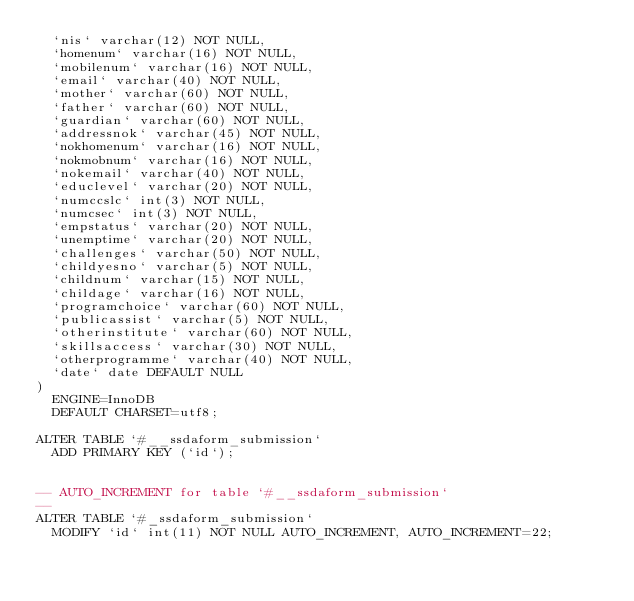<code> <loc_0><loc_0><loc_500><loc_500><_SQL_>  `nis` varchar(12) NOT NULL,
  `homenum` varchar(16) NOT NULL,
  `mobilenum` varchar(16) NOT NULL,
  `email` varchar(40) NOT NULL,
  `mother` varchar(60) NOT NULL,
  `father` varchar(60) NOT NULL,
  `guardian` varchar(60) NOT NULL,
  `addressnok` varchar(45) NOT NULL,
  `nokhomenum` varchar(16) NOT NULL,
  `nokmobnum` varchar(16) NOT NULL,
  `nokemail` varchar(40) NOT NULL,
  `educlevel` varchar(20) NOT NULL,
  `numccslc` int(3) NOT NULL,
  `numcsec` int(3) NOT NULL,
  `empstatus` varchar(20) NOT NULL,
  `unemptime` varchar(20) NOT NULL,
  `challenges` varchar(50) NOT NULL,
  `childyesno` varchar(5) NOT NULL,
  `childnum` varchar(15) NOT NULL,
  `childage` varchar(16) NOT NULL,
  `programchoice` varchar(60) NOT NULL,
  `publicassist` varchar(5) NOT NULL,
  `otherinstitute` varchar(60) NOT NULL,
  `skillsaccess` varchar(30) NOT NULL,
  `otherprogramme` varchar(40) NOT NULL,
  `date` date DEFAULT NULL
) 
	ENGINE=InnoDB 
	DEFAULT CHARSET=utf8;
	
ALTER TABLE `#__ssdaform_submission`
  ADD PRIMARY KEY (`id`);


-- AUTO_INCREMENT for table `#__ssdaform_submission`
--
ALTER TABLE `#_ssdaform_submission`
  MODIFY `id` int(11) NOT NULL AUTO_INCREMENT, AUTO_INCREMENT=22;
</code> 